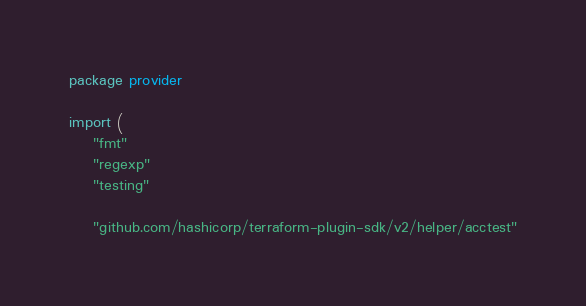<code> <loc_0><loc_0><loc_500><loc_500><_Go_>package provider

import (
	"fmt"
	"regexp"
	"testing"

	"github.com/hashicorp/terraform-plugin-sdk/v2/helper/acctest"</code> 